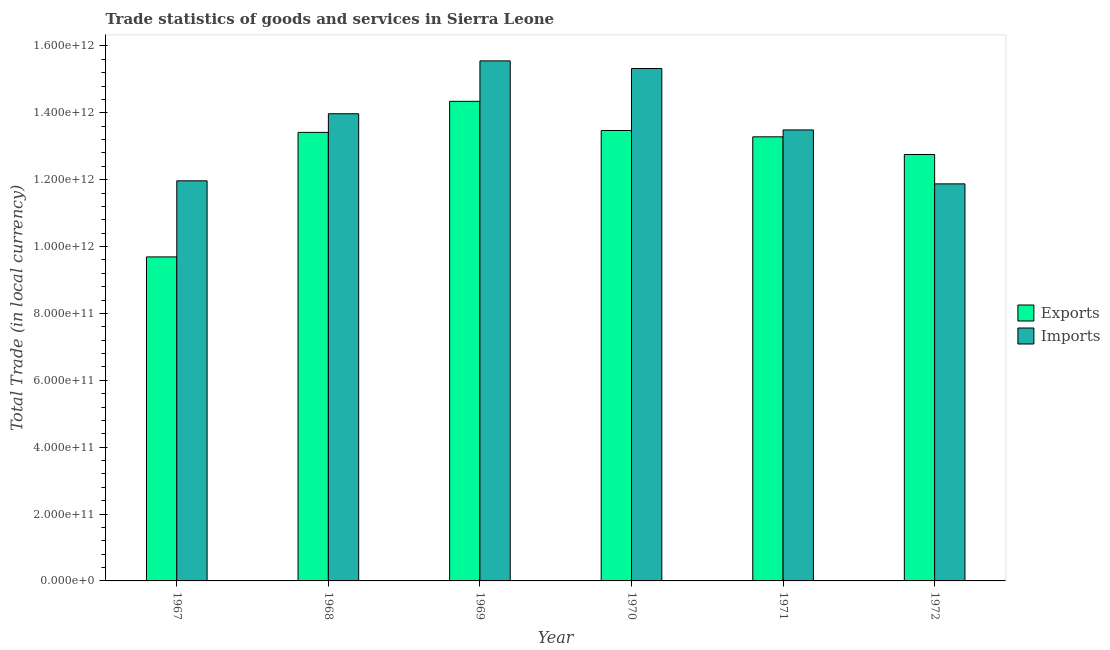Are the number of bars on each tick of the X-axis equal?
Ensure brevity in your answer.  Yes. How many bars are there on the 6th tick from the left?
Ensure brevity in your answer.  2. What is the label of the 1st group of bars from the left?
Offer a very short reply. 1967. What is the imports of goods and services in 1968?
Offer a very short reply. 1.40e+12. Across all years, what is the maximum export of goods and services?
Offer a terse response. 1.43e+12. Across all years, what is the minimum export of goods and services?
Your answer should be compact. 9.69e+11. In which year was the export of goods and services maximum?
Your answer should be compact. 1969. In which year was the imports of goods and services minimum?
Your answer should be very brief. 1972. What is the total export of goods and services in the graph?
Provide a short and direct response. 7.70e+12. What is the difference between the export of goods and services in 1969 and that in 1972?
Your response must be concise. 1.59e+11. What is the difference between the export of goods and services in 1968 and the imports of goods and services in 1967?
Ensure brevity in your answer.  3.73e+11. What is the average imports of goods and services per year?
Your response must be concise. 1.37e+12. In how many years, is the imports of goods and services greater than 80000000000 LCU?
Your response must be concise. 6. What is the ratio of the export of goods and services in 1967 to that in 1971?
Provide a short and direct response. 0.73. Is the difference between the imports of goods and services in 1971 and 1972 greater than the difference between the export of goods and services in 1971 and 1972?
Make the answer very short. No. What is the difference between the highest and the second highest export of goods and services?
Ensure brevity in your answer.  8.73e+1. What is the difference between the highest and the lowest imports of goods and services?
Provide a short and direct response. 3.68e+11. In how many years, is the export of goods and services greater than the average export of goods and services taken over all years?
Keep it short and to the point. 4. What does the 2nd bar from the left in 1971 represents?
Offer a very short reply. Imports. What does the 1st bar from the right in 1967 represents?
Ensure brevity in your answer.  Imports. Are all the bars in the graph horizontal?
Keep it short and to the point. No. What is the difference between two consecutive major ticks on the Y-axis?
Provide a short and direct response. 2.00e+11. Are the values on the major ticks of Y-axis written in scientific E-notation?
Offer a very short reply. Yes. Does the graph contain any zero values?
Give a very brief answer. No. Does the graph contain grids?
Ensure brevity in your answer.  No. How many legend labels are there?
Offer a very short reply. 2. How are the legend labels stacked?
Your answer should be compact. Vertical. What is the title of the graph?
Make the answer very short. Trade statistics of goods and services in Sierra Leone. Does "% of gross capital formation" appear as one of the legend labels in the graph?
Make the answer very short. No. What is the label or title of the X-axis?
Provide a succinct answer. Year. What is the label or title of the Y-axis?
Give a very brief answer. Total Trade (in local currency). What is the Total Trade (in local currency) of Exports in 1967?
Offer a very short reply. 9.69e+11. What is the Total Trade (in local currency) of Imports in 1967?
Your response must be concise. 1.20e+12. What is the Total Trade (in local currency) of Exports in 1968?
Provide a short and direct response. 1.34e+12. What is the Total Trade (in local currency) in Imports in 1968?
Offer a terse response. 1.40e+12. What is the Total Trade (in local currency) of Exports in 1969?
Your answer should be very brief. 1.43e+12. What is the Total Trade (in local currency) in Imports in 1969?
Keep it short and to the point. 1.56e+12. What is the Total Trade (in local currency) in Exports in 1970?
Provide a short and direct response. 1.35e+12. What is the Total Trade (in local currency) in Imports in 1970?
Offer a very short reply. 1.53e+12. What is the Total Trade (in local currency) of Exports in 1971?
Your response must be concise. 1.33e+12. What is the Total Trade (in local currency) of Imports in 1971?
Give a very brief answer. 1.35e+12. What is the Total Trade (in local currency) in Exports in 1972?
Keep it short and to the point. 1.28e+12. What is the Total Trade (in local currency) of Imports in 1972?
Provide a short and direct response. 1.19e+12. Across all years, what is the maximum Total Trade (in local currency) of Exports?
Your answer should be compact. 1.43e+12. Across all years, what is the maximum Total Trade (in local currency) in Imports?
Your answer should be compact. 1.56e+12. Across all years, what is the minimum Total Trade (in local currency) of Exports?
Your answer should be very brief. 9.69e+11. Across all years, what is the minimum Total Trade (in local currency) in Imports?
Your response must be concise. 1.19e+12. What is the total Total Trade (in local currency) of Exports in the graph?
Your response must be concise. 7.70e+12. What is the total Total Trade (in local currency) in Imports in the graph?
Provide a succinct answer. 8.22e+12. What is the difference between the Total Trade (in local currency) of Exports in 1967 and that in 1968?
Provide a short and direct response. -3.73e+11. What is the difference between the Total Trade (in local currency) of Imports in 1967 and that in 1968?
Your answer should be compact. -2.01e+11. What is the difference between the Total Trade (in local currency) in Exports in 1967 and that in 1969?
Keep it short and to the point. -4.65e+11. What is the difference between the Total Trade (in local currency) of Imports in 1967 and that in 1969?
Your answer should be very brief. -3.59e+11. What is the difference between the Total Trade (in local currency) in Exports in 1967 and that in 1970?
Keep it short and to the point. -3.78e+11. What is the difference between the Total Trade (in local currency) in Imports in 1967 and that in 1970?
Give a very brief answer. -3.36e+11. What is the difference between the Total Trade (in local currency) of Exports in 1967 and that in 1971?
Your answer should be very brief. -3.59e+11. What is the difference between the Total Trade (in local currency) of Imports in 1967 and that in 1971?
Your response must be concise. -1.52e+11. What is the difference between the Total Trade (in local currency) in Exports in 1967 and that in 1972?
Provide a succinct answer. -3.06e+11. What is the difference between the Total Trade (in local currency) of Imports in 1967 and that in 1972?
Make the answer very short. 9.08e+09. What is the difference between the Total Trade (in local currency) in Exports in 1968 and that in 1969?
Offer a very short reply. -9.29e+1. What is the difference between the Total Trade (in local currency) of Imports in 1968 and that in 1969?
Your answer should be very brief. -1.58e+11. What is the difference between the Total Trade (in local currency) in Exports in 1968 and that in 1970?
Give a very brief answer. -5.54e+09. What is the difference between the Total Trade (in local currency) of Imports in 1968 and that in 1970?
Offer a very short reply. -1.35e+11. What is the difference between the Total Trade (in local currency) in Exports in 1968 and that in 1971?
Your answer should be compact. 1.33e+1. What is the difference between the Total Trade (in local currency) in Imports in 1968 and that in 1971?
Offer a terse response. 4.84e+1. What is the difference between the Total Trade (in local currency) in Exports in 1968 and that in 1972?
Offer a very short reply. 6.62e+1. What is the difference between the Total Trade (in local currency) in Imports in 1968 and that in 1972?
Offer a terse response. 2.10e+11. What is the difference between the Total Trade (in local currency) in Exports in 1969 and that in 1970?
Offer a very short reply. 8.73e+1. What is the difference between the Total Trade (in local currency) of Imports in 1969 and that in 1970?
Your answer should be very brief. 2.29e+1. What is the difference between the Total Trade (in local currency) of Exports in 1969 and that in 1971?
Your answer should be compact. 1.06e+11. What is the difference between the Total Trade (in local currency) in Imports in 1969 and that in 1971?
Your response must be concise. 2.07e+11. What is the difference between the Total Trade (in local currency) of Exports in 1969 and that in 1972?
Provide a succinct answer. 1.59e+11. What is the difference between the Total Trade (in local currency) of Imports in 1969 and that in 1972?
Give a very brief answer. 3.68e+11. What is the difference between the Total Trade (in local currency) of Exports in 1970 and that in 1971?
Offer a terse response. 1.88e+1. What is the difference between the Total Trade (in local currency) of Imports in 1970 and that in 1971?
Offer a terse response. 1.84e+11. What is the difference between the Total Trade (in local currency) in Exports in 1970 and that in 1972?
Your answer should be very brief. 7.17e+1. What is the difference between the Total Trade (in local currency) of Imports in 1970 and that in 1972?
Make the answer very short. 3.45e+11. What is the difference between the Total Trade (in local currency) in Exports in 1971 and that in 1972?
Offer a very short reply. 5.29e+1. What is the difference between the Total Trade (in local currency) of Imports in 1971 and that in 1972?
Give a very brief answer. 1.61e+11. What is the difference between the Total Trade (in local currency) in Exports in 1967 and the Total Trade (in local currency) in Imports in 1968?
Offer a very short reply. -4.28e+11. What is the difference between the Total Trade (in local currency) in Exports in 1967 and the Total Trade (in local currency) in Imports in 1969?
Keep it short and to the point. -5.86e+11. What is the difference between the Total Trade (in local currency) of Exports in 1967 and the Total Trade (in local currency) of Imports in 1970?
Provide a succinct answer. -5.63e+11. What is the difference between the Total Trade (in local currency) in Exports in 1967 and the Total Trade (in local currency) in Imports in 1971?
Your answer should be very brief. -3.80e+11. What is the difference between the Total Trade (in local currency) of Exports in 1967 and the Total Trade (in local currency) of Imports in 1972?
Make the answer very short. -2.18e+11. What is the difference between the Total Trade (in local currency) of Exports in 1968 and the Total Trade (in local currency) of Imports in 1969?
Your response must be concise. -2.14e+11. What is the difference between the Total Trade (in local currency) of Exports in 1968 and the Total Trade (in local currency) of Imports in 1970?
Ensure brevity in your answer.  -1.91e+11. What is the difference between the Total Trade (in local currency) in Exports in 1968 and the Total Trade (in local currency) in Imports in 1971?
Keep it short and to the point. -7.28e+09. What is the difference between the Total Trade (in local currency) in Exports in 1968 and the Total Trade (in local currency) in Imports in 1972?
Your response must be concise. 1.54e+11. What is the difference between the Total Trade (in local currency) of Exports in 1969 and the Total Trade (in local currency) of Imports in 1970?
Your answer should be compact. -9.81e+1. What is the difference between the Total Trade (in local currency) of Exports in 1969 and the Total Trade (in local currency) of Imports in 1971?
Your answer should be very brief. 8.56e+1. What is the difference between the Total Trade (in local currency) of Exports in 1969 and the Total Trade (in local currency) of Imports in 1972?
Offer a very short reply. 2.47e+11. What is the difference between the Total Trade (in local currency) in Exports in 1970 and the Total Trade (in local currency) in Imports in 1971?
Provide a short and direct response. -1.75e+09. What is the difference between the Total Trade (in local currency) in Exports in 1970 and the Total Trade (in local currency) in Imports in 1972?
Your answer should be compact. 1.60e+11. What is the difference between the Total Trade (in local currency) in Exports in 1971 and the Total Trade (in local currency) in Imports in 1972?
Your response must be concise. 1.41e+11. What is the average Total Trade (in local currency) of Exports per year?
Offer a very short reply. 1.28e+12. What is the average Total Trade (in local currency) of Imports per year?
Give a very brief answer. 1.37e+12. In the year 1967, what is the difference between the Total Trade (in local currency) in Exports and Total Trade (in local currency) in Imports?
Give a very brief answer. -2.28e+11. In the year 1968, what is the difference between the Total Trade (in local currency) in Exports and Total Trade (in local currency) in Imports?
Ensure brevity in your answer.  -5.57e+1. In the year 1969, what is the difference between the Total Trade (in local currency) of Exports and Total Trade (in local currency) of Imports?
Your answer should be compact. -1.21e+11. In the year 1970, what is the difference between the Total Trade (in local currency) of Exports and Total Trade (in local currency) of Imports?
Your answer should be compact. -1.85e+11. In the year 1971, what is the difference between the Total Trade (in local currency) of Exports and Total Trade (in local currency) of Imports?
Your answer should be very brief. -2.06e+1. In the year 1972, what is the difference between the Total Trade (in local currency) in Exports and Total Trade (in local currency) in Imports?
Provide a succinct answer. 8.78e+1. What is the ratio of the Total Trade (in local currency) of Exports in 1967 to that in 1968?
Provide a succinct answer. 0.72. What is the ratio of the Total Trade (in local currency) in Imports in 1967 to that in 1968?
Your answer should be very brief. 0.86. What is the ratio of the Total Trade (in local currency) of Exports in 1967 to that in 1969?
Offer a terse response. 0.68. What is the ratio of the Total Trade (in local currency) of Imports in 1967 to that in 1969?
Ensure brevity in your answer.  0.77. What is the ratio of the Total Trade (in local currency) in Exports in 1967 to that in 1970?
Your response must be concise. 0.72. What is the ratio of the Total Trade (in local currency) in Imports in 1967 to that in 1970?
Offer a terse response. 0.78. What is the ratio of the Total Trade (in local currency) in Exports in 1967 to that in 1971?
Ensure brevity in your answer.  0.73. What is the ratio of the Total Trade (in local currency) in Imports in 1967 to that in 1971?
Make the answer very short. 0.89. What is the ratio of the Total Trade (in local currency) in Exports in 1967 to that in 1972?
Your response must be concise. 0.76. What is the ratio of the Total Trade (in local currency) of Imports in 1967 to that in 1972?
Your answer should be compact. 1.01. What is the ratio of the Total Trade (in local currency) of Exports in 1968 to that in 1969?
Keep it short and to the point. 0.94. What is the ratio of the Total Trade (in local currency) of Imports in 1968 to that in 1969?
Provide a short and direct response. 0.9. What is the ratio of the Total Trade (in local currency) in Imports in 1968 to that in 1970?
Offer a terse response. 0.91. What is the ratio of the Total Trade (in local currency) in Imports in 1968 to that in 1971?
Provide a succinct answer. 1.04. What is the ratio of the Total Trade (in local currency) in Exports in 1968 to that in 1972?
Your answer should be very brief. 1.05. What is the ratio of the Total Trade (in local currency) of Imports in 1968 to that in 1972?
Make the answer very short. 1.18. What is the ratio of the Total Trade (in local currency) of Exports in 1969 to that in 1970?
Provide a short and direct response. 1.06. What is the ratio of the Total Trade (in local currency) of Imports in 1969 to that in 1970?
Your answer should be compact. 1.01. What is the ratio of the Total Trade (in local currency) in Exports in 1969 to that in 1971?
Provide a succinct answer. 1.08. What is the ratio of the Total Trade (in local currency) in Imports in 1969 to that in 1971?
Offer a terse response. 1.15. What is the ratio of the Total Trade (in local currency) of Exports in 1969 to that in 1972?
Offer a terse response. 1.12. What is the ratio of the Total Trade (in local currency) in Imports in 1969 to that in 1972?
Give a very brief answer. 1.31. What is the ratio of the Total Trade (in local currency) of Exports in 1970 to that in 1971?
Keep it short and to the point. 1.01. What is the ratio of the Total Trade (in local currency) in Imports in 1970 to that in 1971?
Ensure brevity in your answer.  1.14. What is the ratio of the Total Trade (in local currency) of Exports in 1970 to that in 1972?
Your answer should be very brief. 1.06. What is the ratio of the Total Trade (in local currency) of Imports in 1970 to that in 1972?
Provide a succinct answer. 1.29. What is the ratio of the Total Trade (in local currency) in Exports in 1971 to that in 1972?
Keep it short and to the point. 1.04. What is the ratio of the Total Trade (in local currency) of Imports in 1971 to that in 1972?
Your response must be concise. 1.14. What is the difference between the highest and the second highest Total Trade (in local currency) of Exports?
Give a very brief answer. 8.73e+1. What is the difference between the highest and the second highest Total Trade (in local currency) in Imports?
Your answer should be compact. 2.29e+1. What is the difference between the highest and the lowest Total Trade (in local currency) of Exports?
Offer a terse response. 4.65e+11. What is the difference between the highest and the lowest Total Trade (in local currency) of Imports?
Keep it short and to the point. 3.68e+11. 